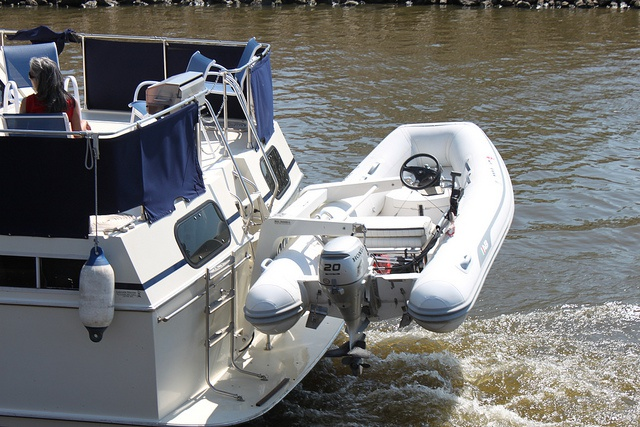Describe the objects in this image and their specific colors. I can see boat in black, gray, white, and darkgray tones, people in black, maroon, gray, and darkgray tones, chair in black, gray, lightgray, blue, and darkgray tones, chair in black, navy, darkgray, and gray tones, and chair in black, blue, lightgray, and gray tones in this image. 